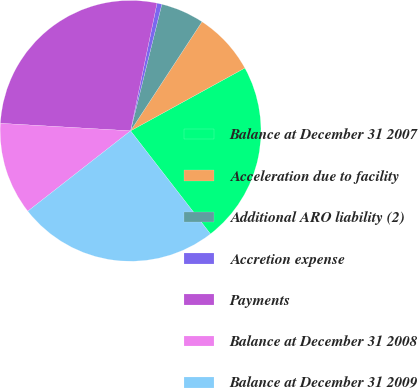Convert chart to OTSL. <chart><loc_0><loc_0><loc_500><loc_500><pie_chart><fcel>Balance at December 31 2007<fcel>Acceleration due to facility<fcel>Additional ARO liability (2)<fcel>Accretion expense<fcel>Payments<fcel>Balance at December 31 2008<fcel>Balance at December 31 2009<nl><fcel>22.51%<fcel>7.78%<fcel>5.37%<fcel>0.6%<fcel>27.34%<fcel>11.48%<fcel>24.93%<nl></chart> 